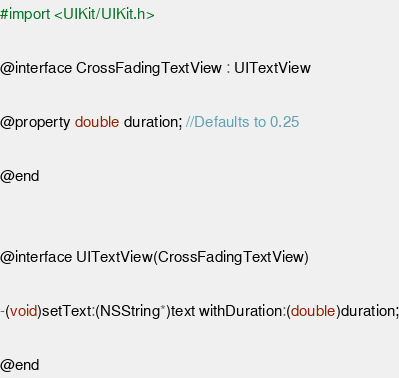Convert code to text. <code><loc_0><loc_0><loc_500><loc_500><_C_>#import <UIKit/UIKit.h>

@interface CrossFadingTextView : UITextView

@property double duration; //Defaults to 0.25

@end


@interface UITextView(CrossFadingTextView)

-(void)setText:(NSString*)text withDuration:(double)duration;

@end</code> 